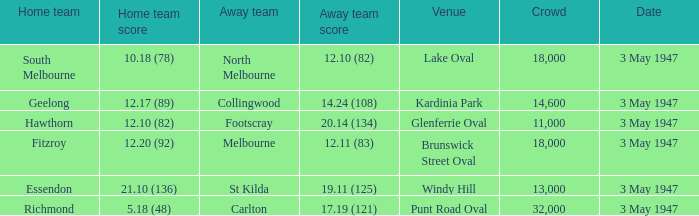Which venue did the away team score 12.10 (82)? Lake Oval. Can you parse all the data within this table? {'header': ['Home team', 'Home team score', 'Away team', 'Away team score', 'Venue', 'Crowd', 'Date'], 'rows': [['South Melbourne', '10.18 (78)', 'North Melbourne', '12.10 (82)', 'Lake Oval', '18,000', '3 May 1947'], ['Geelong', '12.17 (89)', 'Collingwood', '14.24 (108)', 'Kardinia Park', '14,600', '3 May 1947'], ['Hawthorn', '12.10 (82)', 'Footscray', '20.14 (134)', 'Glenferrie Oval', '11,000', '3 May 1947'], ['Fitzroy', '12.20 (92)', 'Melbourne', '12.11 (83)', 'Brunswick Street Oval', '18,000', '3 May 1947'], ['Essendon', '21.10 (136)', 'St Kilda', '19.11 (125)', 'Windy Hill', '13,000', '3 May 1947'], ['Richmond', '5.18 (48)', 'Carlton', '17.19 (121)', 'Punt Road Oval', '32,000', '3 May 1947']]} 